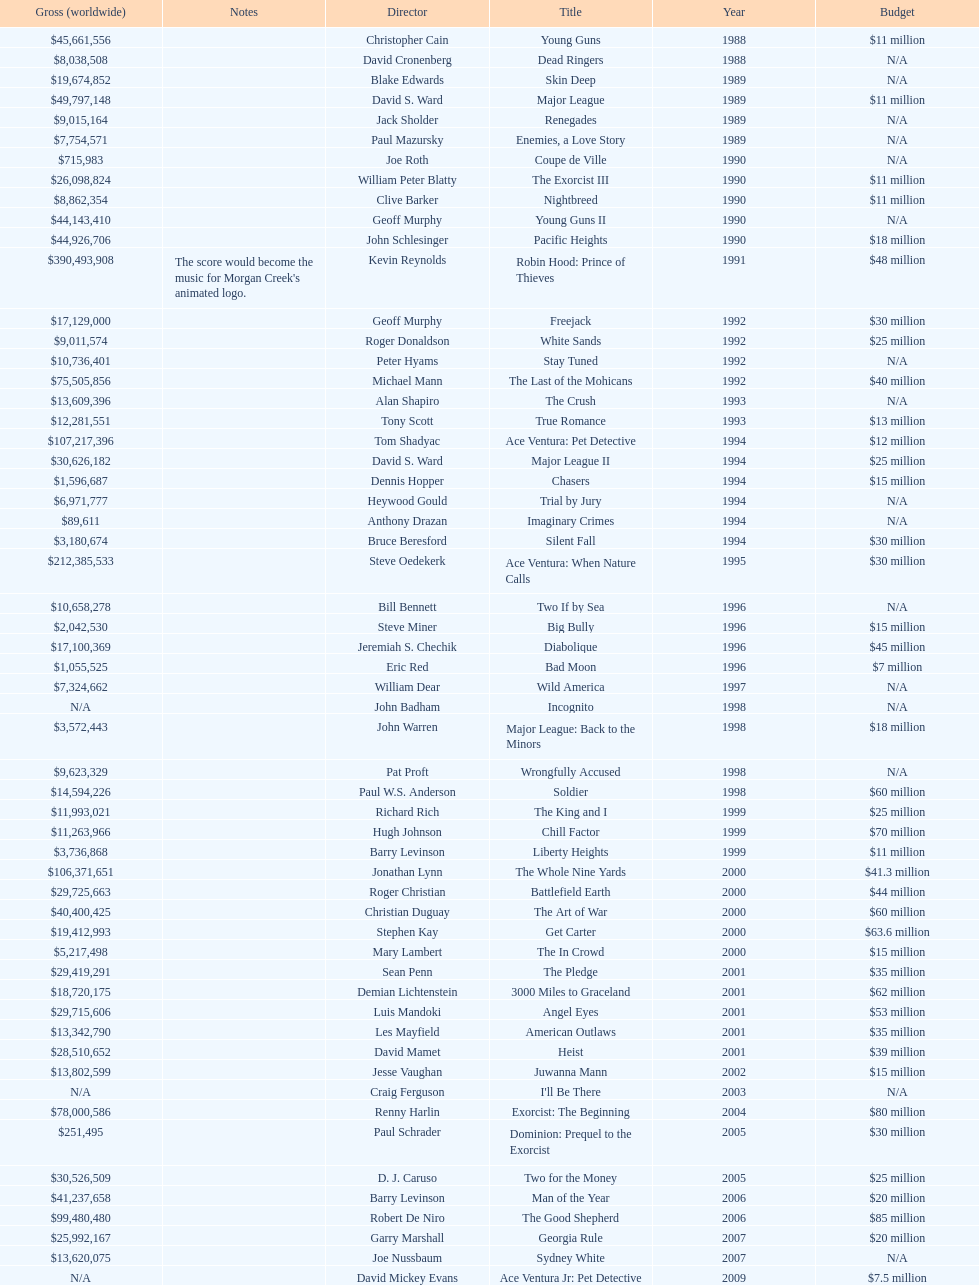Which film had a higher budget, ace ventura: when nature calls, or major league: back to the minors? Ace Ventura: When Nature Calls. 